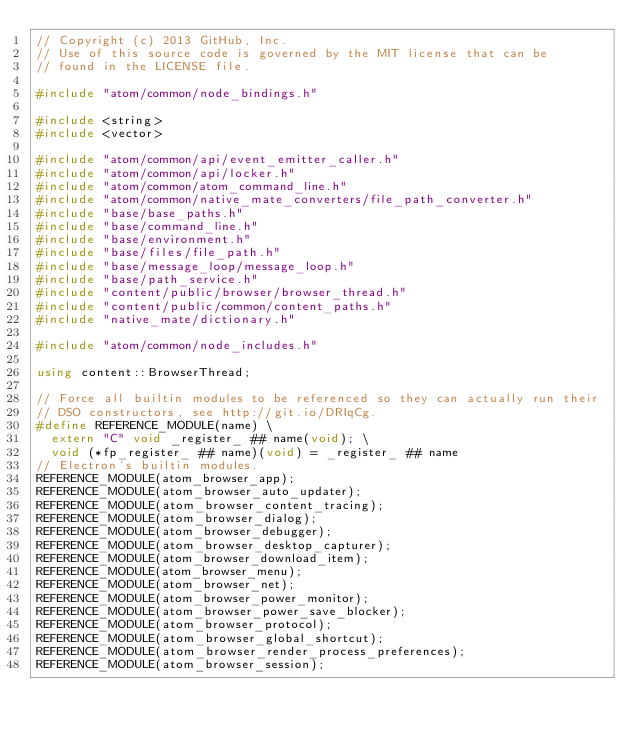<code> <loc_0><loc_0><loc_500><loc_500><_C++_>// Copyright (c) 2013 GitHub, Inc.
// Use of this source code is governed by the MIT license that can be
// found in the LICENSE file.

#include "atom/common/node_bindings.h"

#include <string>
#include <vector>

#include "atom/common/api/event_emitter_caller.h"
#include "atom/common/api/locker.h"
#include "atom/common/atom_command_line.h"
#include "atom/common/native_mate_converters/file_path_converter.h"
#include "base/base_paths.h"
#include "base/command_line.h"
#include "base/environment.h"
#include "base/files/file_path.h"
#include "base/message_loop/message_loop.h"
#include "base/path_service.h"
#include "content/public/browser/browser_thread.h"
#include "content/public/common/content_paths.h"
#include "native_mate/dictionary.h"

#include "atom/common/node_includes.h"

using content::BrowserThread;

// Force all builtin modules to be referenced so they can actually run their
// DSO constructors, see http://git.io/DRIqCg.
#define REFERENCE_MODULE(name) \
  extern "C" void _register_ ## name(void); \
  void (*fp_register_ ## name)(void) = _register_ ## name
// Electron's builtin modules.
REFERENCE_MODULE(atom_browser_app);
REFERENCE_MODULE(atom_browser_auto_updater);
REFERENCE_MODULE(atom_browser_content_tracing);
REFERENCE_MODULE(atom_browser_dialog);
REFERENCE_MODULE(atom_browser_debugger);
REFERENCE_MODULE(atom_browser_desktop_capturer);
REFERENCE_MODULE(atom_browser_download_item);
REFERENCE_MODULE(atom_browser_menu);
REFERENCE_MODULE(atom_browser_net);
REFERENCE_MODULE(atom_browser_power_monitor);
REFERENCE_MODULE(atom_browser_power_save_blocker);
REFERENCE_MODULE(atom_browser_protocol);
REFERENCE_MODULE(atom_browser_global_shortcut);
REFERENCE_MODULE(atom_browser_render_process_preferences);
REFERENCE_MODULE(atom_browser_session);</code> 